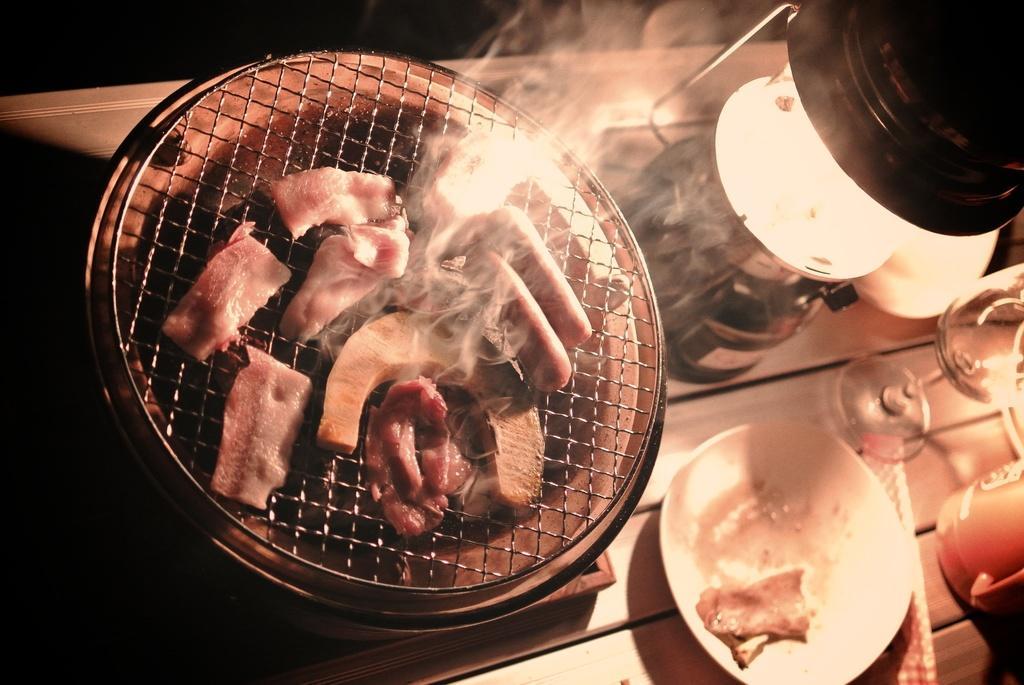Can you describe this image briefly? Here in this picture we can see a table present, on which we can see a grill pan present, where meat is being grilled over there and beside that we can see a bowl, a lantern and a glass present over there. 